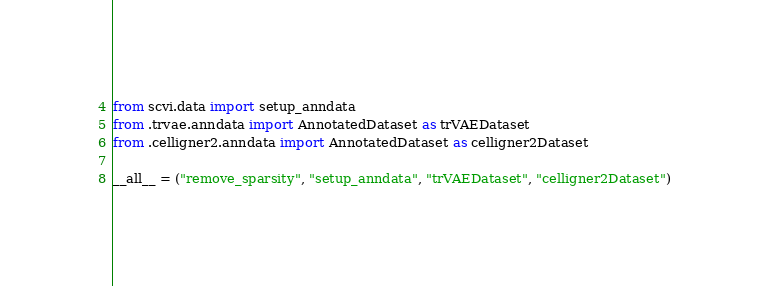Convert code to text. <code><loc_0><loc_0><loc_500><loc_500><_Python_>from scvi.data import setup_anndata
from .trvae.anndata import AnnotatedDataset as trVAEDataset
from .celligner2.anndata import AnnotatedDataset as celligner2Dataset

__all__ = ("remove_sparsity", "setup_anndata", "trVAEDataset", "celligner2Dataset")
</code> 